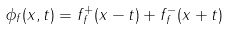<formula> <loc_0><loc_0><loc_500><loc_500>\phi _ { f } ( x , t ) = f _ { f } ^ { + } ( x - t ) + f _ { f } ^ { - } ( x + t )</formula> 